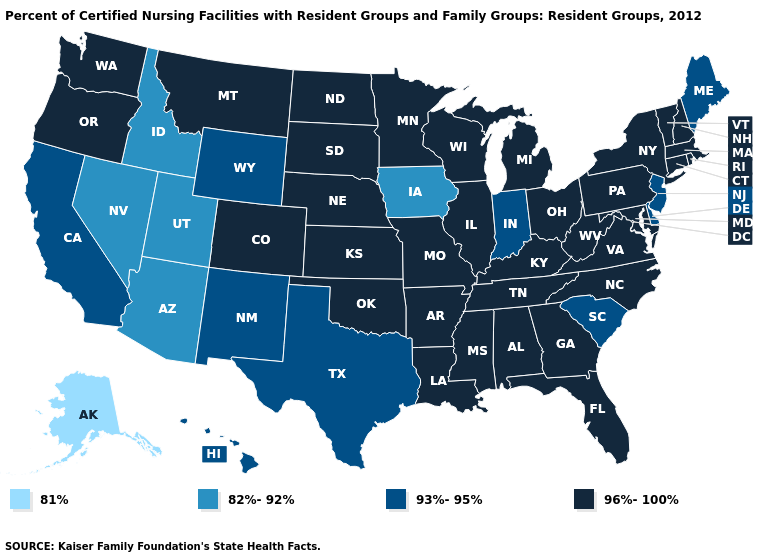Does Kentucky have the lowest value in the USA?
Quick response, please. No. Which states have the highest value in the USA?
Concise answer only. Alabama, Arkansas, Colorado, Connecticut, Florida, Georgia, Illinois, Kansas, Kentucky, Louisiana, Maryland, Massachusetts, Michigan, Minnesota, Mississippi, Missouri, Montana, Nebraska, New Hampshire, New York, North Carolina, North Dakota, Ohio, Oklahoma, Oregon, Pennsylvania, Rhode Island, South Dakota, Tennessee, Vermont, Virginia, Washington, West Virginia, Wisconsin. What is the highest value in states that border Nevada?
Be succinct. 96%-100%. Does Minnesota have the lowest value in the MidWest?
Give a very brief answer. No. What is the value of New York?
Keep it brief. 96%-100%. Name the states that have a value in the range 96%-100%?
Quick response, please. Alabama, Arkansas, Colorado, Connecticut, Florida, Georgia, Illinois, Kansas, Kentucky, Louisiana, Maryland, Massachusetts, Michigan, Minnesota, Mississippi, Missouri, Montana, Nebraska, New Hampshire, New York, North Carolina, North Dakota, Ohio, Oklahoma, Oregon, Pennsylvania, Rhode Island, South Dakota, Tennessee, Vermont, Virginia, Washington, West Virginia, Wisconsin. What is the value of Louisiana?
Short answer required. 96%-100%. Name the states that have a value in the range 96%-100%?
Answer briefly. Alabama, Arkansas, Colorado, Connecticut, Florida, Georgia, Illinois, Kansas, Kentucky, Louisiana, Maryland, Massachusetts, Michigan, Minnesota, Mississippi, Missouri, Montana, Nebraska, New Hampshire, New York, North Carolina, North Dakota, Ohio, Oklahoma, Oregon, Pennsylvania, Rhode Island, South Dakota, Tennessee, Vermont, Virginia, Washington, West Virginia, Wisconsin. Name the states that have a value in the range 93%-95%?
Be succinct. California, Delaware, Hawaii, Indiana, Maine, New Jersey, New Mexico, South Carolina, Texas, Wyoming. Which states have the highest value in the USA?
Give a very brief answer. Alabama, Arkansas, Colorado, Connecticut, Florida, Georgia, Illinois, Kansas, Kentucky, Louisiana, Maryland, Massachusetts, Michigan, Minnesota, Mississippi, Missouri, Montana, Nebraska, New Hampshire, New York, North Carolina, North Dakota, Ohio, Oklahoma, Oregon, Pennsylvania, Rhode Island, South Dakota, Tennessee, Vermont, Virginia, Washington, West Virginia, Wisconsin. Does Nevada have a lower value than Nebraska?
Answer briefly. Yes. Does Louisiana have a lower value than Iowa?
Give a very brief answer. No. Which states have the highest value in the USA?
Keep it brief. Alabama, Arkansas, Colorado, Connecticut, Florida, Georgia, Illinois, Kansas, Kentucky, Louisiana, Maryland, Massachusetts, Michigan, Minnesota, Mississippi, Missouri, Montana, Nebraska, New Hampshire, New York, North Carolina, North Dakota, Ohio, Oklahoma, Oregon, Pennsylvania, Rhode Island, South Dakota, Tennessee, Vermont, Virginia, Washington, West Virginia, Wisconsin. What is the highest value in states that border Nevada?
Give a very brief answer. 96%-100%. Name the states that have a value in the range 81%?
Quick response, please. Alaska. 